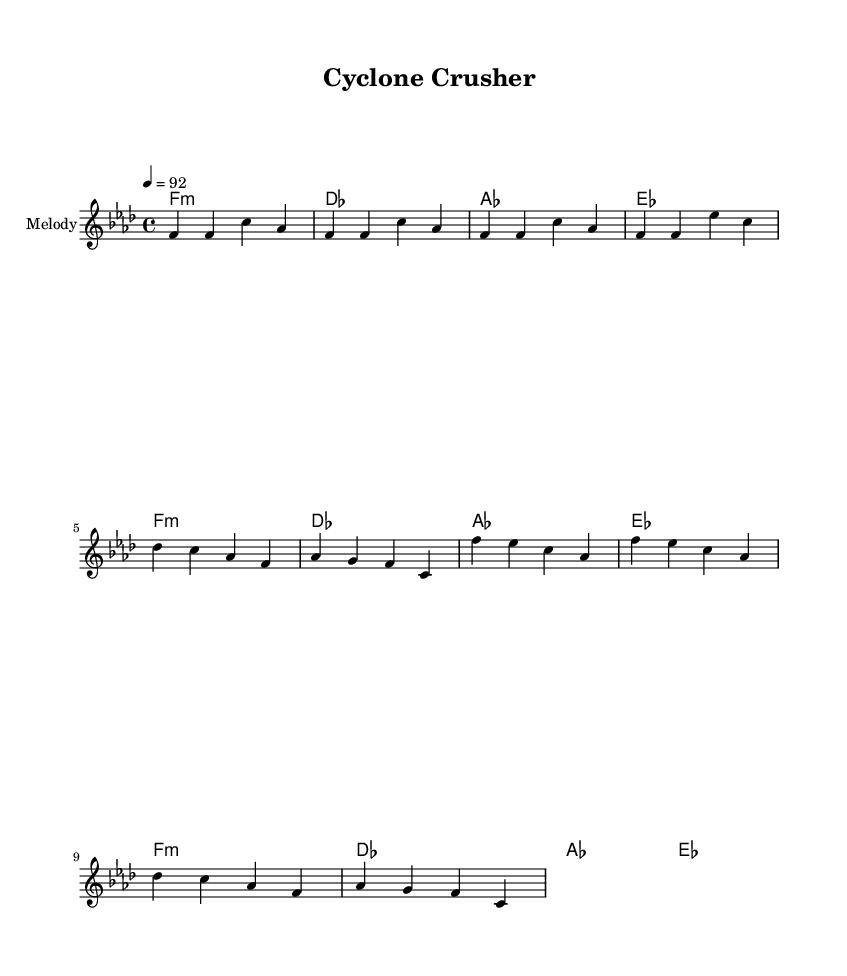What is the key signature of this music? The key signature is F minor, indicated by four flats in the key signature.
Answer: F minor What is the time signature of the piece? The time signature shown in the sheet music is 4/4, which means there are four beats in a measure.
Answer: 4/4 What is the tempo marking for this composition? The tempo marking is indicated as 4 = 92, meaning the quarter note should be played at a speed of 92 beats per minute.
Answer: 92 How many measures are there in the melody section? The melody section consists of 8 measures, as indicated by the groupings of notes and bars shown in the notation.
Answer: 8 What is the first chord in the harmony section? The first chord in the harmony section is F minor, which is labeled at the beginning of the chord progression.
Answer: F minor Which section follows the verse in the structure of the music? The section that follows the verse is the chorus, as indicated by the grouping of music notation that usually emphasizes the main themes of the piece.
Answer: Chorus How many times is the chord sequence repeated in the piece? The chord sequence is repeated two times in the piece, as it appears in two successive groups in the harmony section.
Answer: 2 